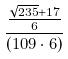Convert formula to latex. <formula><loc_0><loc_0><loc_500><loc_500>\frac { \frac { \sqrt { 2 3 5 } + 1 7 } { 6 } } { ( 1 0 9 \cdot 6 ) }</formula> 